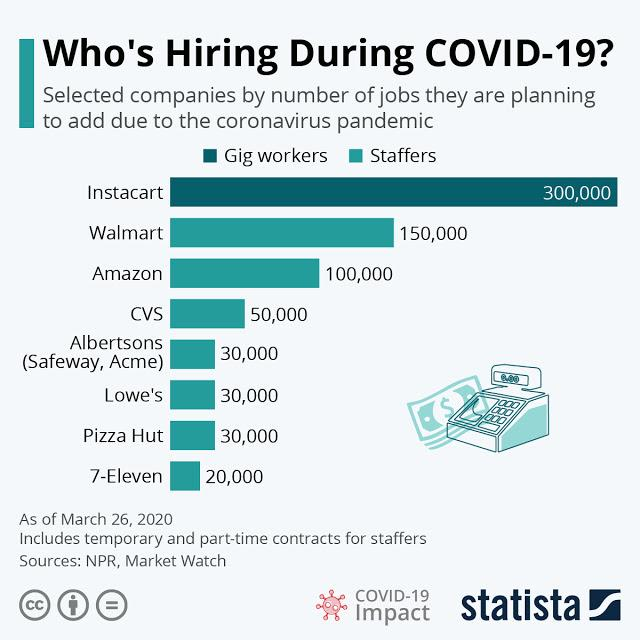Mention a couple of crucial points in this snapshot. Walmart has announced that it plans to add the second highest number of jobs among the selected companies due to the Coronavirus pandemic as of March 26, 2020. 7-Eleven is the company that has announced plans to reduce the number of jobs the most among the selected companies due to the COVID-19 pandemic as of March 26, 2020. As of March 26, 2020, it was reported that Amazon planned to add 100,000 new jobs due to the COVID-19 pandemic. As of March 26, 2020, Walmart had announced that it intended to create 150,000 new jobs in response to the Coronavirus pandemic. As of March 26, 2020, it is expected that Instacart will add the highest number of jobs among the selected companies due to the COVID-19 pandemic. 